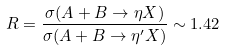<formula> <loc_0><loc_0><loc_500><loc_500>R = \frac { \sigma ( A + B \rightarrow \eta X ) } { \sigma ( A + B \rightarrow \eta ^ { \prime } X ) } \sim 1 . 4 2</formula> 